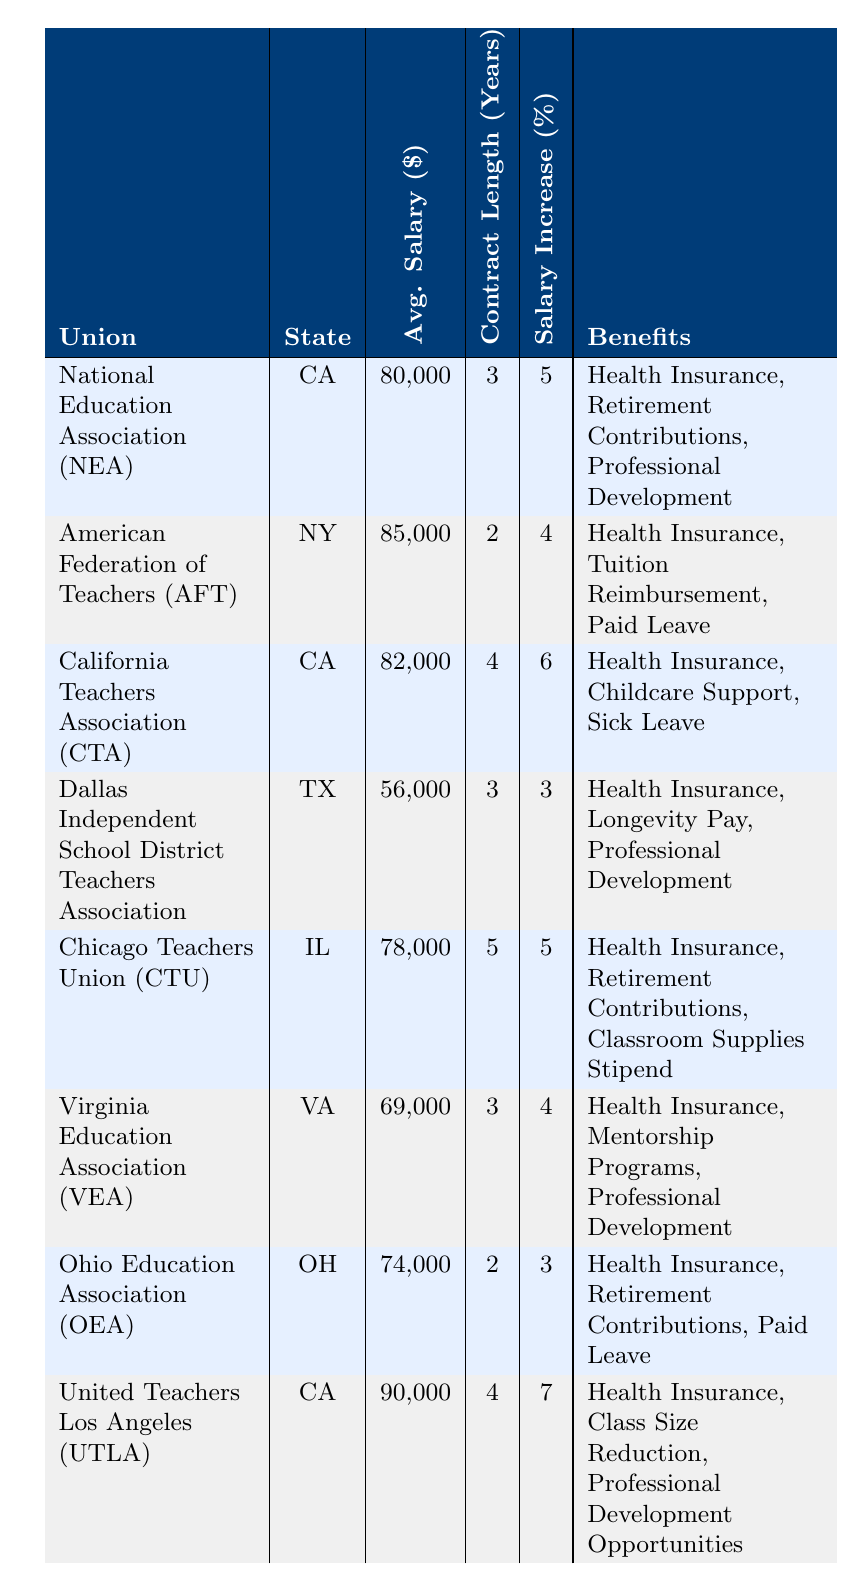What is the average teacher salary in California? From the table, the average teacher salaries for the unions in California are 80000 (NEA), 82000 (CTA), and 90000 (UTLA). To find the average, we sum these values: 80000 + 82000 + 90000 = 252000. Then, divide by the number of unions (3): 252000 / 3 = 84000.
Answer: 84000 Which union has the highest average teacher salary? Reviewing the table, the average salaries are 80000 (NEA), 85000 (AFT), 82000 (CTA), 56000 (Dallas), 78000 (CTU), 69000 (VEA), 74000 (OEA), and 90000 (UTLA). The highest value is 90000 from the United Teachers Los Angeles (UTLA).
Answer: United Teachers Los Angeles (UTLA) Do all unions provide health insurance as a benefit? Looking across the benefits listed for each union, every union indeed includes "Health Insurance" as part of their benefits. Therefore, the answer is yes.
Answer: Yes What is the difference in average teacher salary between the union with the highest percentage salary increase and the one with the lowest? The union with the highest increase is United Teachers Los Angeles (UTLA) with a 7% increase and an average salary of 90000. The lowest is Dallas Independent School District Teachers Association (Dallas) with a 3% increase and an average salary of 56000. The difference in average salary is 90000 - 56000 = 34000.
Answer: 34000 How many unions have a contract length of 3 years? By checking the table, the unions with a contract length of 3 years are NEA, Dallas, and VEA—totaling 3 unions.
Answer: 3 